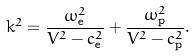Convert formula to latex. <formula><loc_0><loc_0><loc_500><loc_500>k ^ { 2 } = \frac { \omega _ { \mathrm e } ^ { 2 } } { V ^ { 2 } - c _ { \mathrm e } ^ { 2 } } + \frac { \omega _ { \mathrm p } ^ { 2 } } { V ^ { 2 } - c _ { \mathrm p } ^ { 2 } } .</formula> 